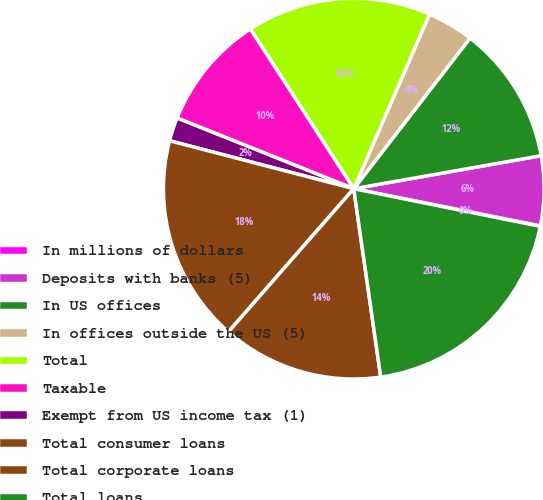Convert chart to OTSL. <chart><loc_0><loc_0><loc_500><loc_500><pie_chart><fcel>In millions of dollars<fcel>Deposits with banks (5)<fcel>In US offices<fcel>In offices outside the US (5)<fcel>Total<fcel>Taxable<fcel>Exempt from US income tax (1)<fcel>Total consumer loans<fcel>Total corporate loans<fcel>Total loans<nl><fcel>0.05%<fcel>5.9%<fcel>11.76%<fcel>3.95%<fcel>15.66%<fcel>9.8%<fcel>2.0%<fcel>17.61%<fcel>13.71%<fcel>19.56%<nl></chart> 